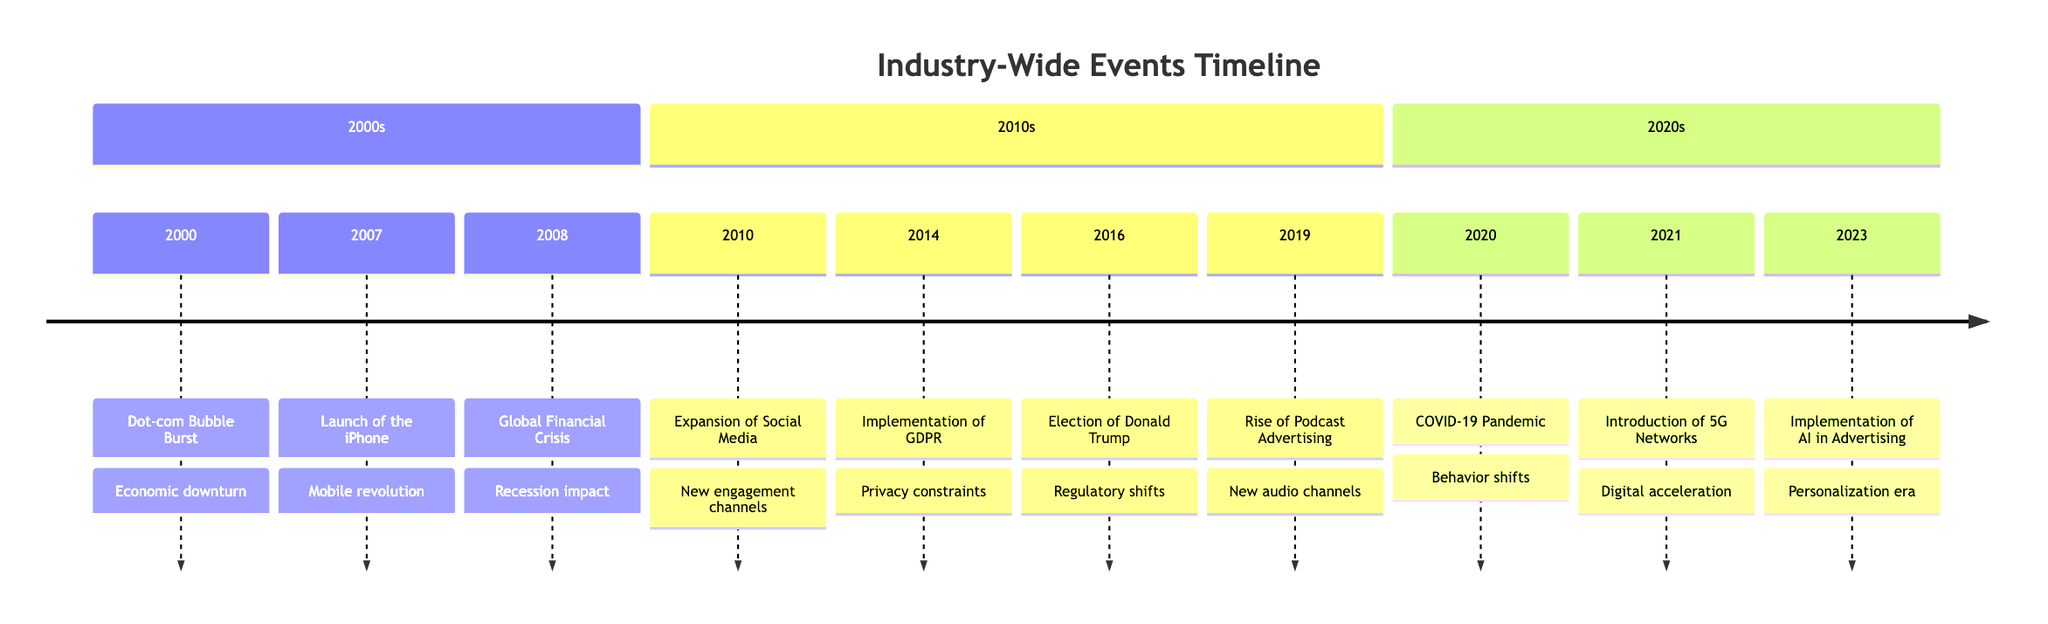What event happened in 2008? The timeline specifies that in 2008, the Global Financial Crisis occurred.
Answer: Global Financial Crisis How many events are listed in the timeline? By counting the entries in the timeline, there are a total of 10 events listed.
Answer: 10 What significant mobile technology event occurred in 2007? According to the timeline, the launch of the iPhone is the significant mobile technology event that occurred in 2007.
Answer: Launch of the iPhone Which event introduced privacy constraints? The implementation of GDPR in 2014 introduced new privacy constraints as indicated on the timeline.
Answer: Implementation of GDPR What trend started in 2019 affecting audio advertising? The rise of podcast advertising, as noted in 2019 on the timeline, affected the audio advertising trend.
Answer: Rise of Podcast Advertising What event represents a shift in consumer behavior due to a global crisis? The COVID-19 pandemic in 2020 represents this shift in consumer behavior according to the timeline.
Answer: COVID-19 Pandemic Which two events occurred in close succession in the 2010s related to regulations? The implementation of GDPR in 2014 and the election of Donald Trump in 2016 are the events related to regulations.
Answer: Implementation of GDPR and Election of Donald Trump What was the technological advancement introduced in 2021? The introduction of 5G networks is the technological advancement noted in 2021 on the timeline.
Answer: Introduction of 5G Networks Which event is associated with personalization in advertising? The implementation of AI in advertising in 2023 is associated with personalization in advertising according to the timeline.
Answer: Implementation of AI in Advertising What was the general impact of events from 2000 to 2010 on advertising budgets? The primary impact on advertising budgets from the events in this time frame is characterized as a downturn, especially noted due to the Dot-com Bubble Burst and the Global Financial Crisis.
Answer: Economic downturn 